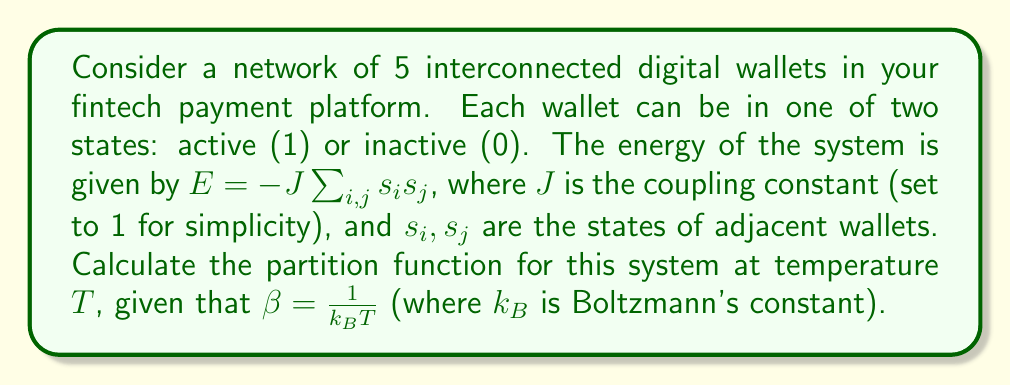What is the answer to this math problem? To calculate the partition function, we need to follow these steps:

1) The partition function is given by:
   $$Z = \sum_{\text{all states}} e^{-\beta E}$$

2) For a system of 5 wallets, there are $2^5 = 32$ possible states.

3) We need to calculate the energy for each state and sum up $e^{-\beta E}$ for all states.

4) For simplicity, let's consider a linear arrangement of wallets. The energy will depend on the number of adjacent active wallets.

5) We can categorize the states based on the number of active wallets:
   - 0 active wallets: 1 state, E = 0
   - 1 active wallet: 5 states, E = 0
   - 2 active wallets: 10 states, 4 with E = -1, 6 with E = 0
   - 3 active wallets: 10 states, 6 with E = -2, 4 with E = -1
   - 4 active wallets: 5 states, E = -3
   - 5 active wallets: 1 state, E = -4

6) Now we can write out the partition function:
   $$Z = 1 + 5 + (4e^{\beta} + 6) + (6e^{2\beta} + 4e^{\beta}) + 5e^{3\beta} + e^{4\beta}$$

7) Simplifying:
   $$Z = 12 + 8e^{\beta} + 6e^{2\beta} + 5e^{3\beta} + e^{4\beta}$$

This is the final form of the partition function for the given system.
Answer: $Z = 12 + 8e^{\beta} + 6e^{2\beta} + 5e^{3\beta} + e^{4\beta}$ 